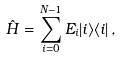<formula> <loc_0><loc_0><loc_500><loc_500>\hat { H } = \sum _ { i = 0 } ^ { N - 1 } E _ { i } | i \rangle \langle i | \, ,</formula> 